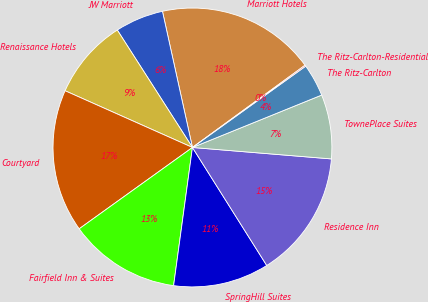Convert chart. <chart><loc_0><loc_0><loc_500><loc_500><pie_chart><fcel>Marriott Hotels<fcel>JW Marriott<fcel>Renaissance Hotels<fcel>Courtyard<fcel>Fairfield Inn & Suites<fcel>SpringHill Suites<fcel>Residence Inn<fcel>TownePlace Suites<fcel>The Ritz-Carlton<fcel>The Ritz-Carlton-Residential<nl><fcel>18.41%<fcel>5.61%<fcel>9.27%<fcel>16.58%<fcel>12.93%<fcel>11.1%<fcel>14.75%<fcel>7.44%<fcel>3.78%<fcel>0.13%<nl></chart> 